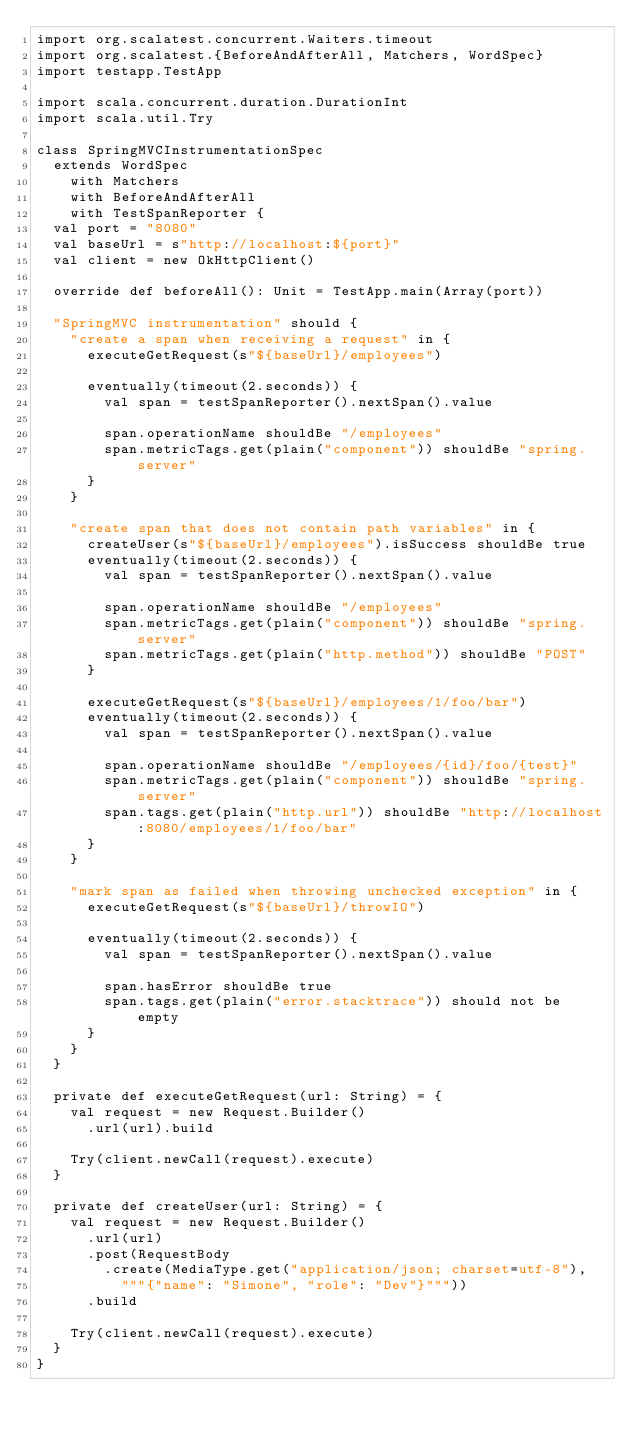<code> <loc_0><loc_0><loc_500><loc_500><_Scala_>import org.scalatest.concurrent.Waiters.timeout
import org.scalatest.{BeforeAndAfterAll, Matchers, WordSpec}
import testapp.TestApp

import scala.concurrent.duration.DurationInt
import scala.util.Try

class SpringMVCInstrumentationSpec
  extends WordSpec
    with Matchers
    with BeforeAndAfterAll
    with TestSpanReporter {
  val port = "8080"
  val baseUrl = s"http://localhost:${port}"
  val client = new OkHttpClient()

  override def beforeAll(): Unit = TestApp.main(Array(port))

  "SpringMVC instrumentation" should {
    "create a span when receiving a request" in {
      executeGetRequest(s"${baseUrl}/employees")

      eventually(timeout(2.seconds)) {
        val span = testSpanReporter().nextSpan().value

        span.operationName shouldBe "/employees"
        span.metricTags.get(plain("component")) shouldBe "spring.server"
      }
    }

    "create span that does not contain path variables" in {
      createUser(s"${baseUrl}/employees").isSuccess shouldBe true
      eventually(timeout(2.seconds)) {
        val span = testSpanReporter().nextSpan().value

        span.operationName shouldBe "/employees"
        span.metricTags.get(plain("component")) shouldBe "spring.server"
        span.metricTags.get(plain("http.method")) shouldBe "POST"
      }

      executeGetRequest(s"${baseUrl}/employees/1/foo/bar")
      eventually(timeout(2.seconds)) {
        val span = testSpanReporter().nextSpan().value

        span.operationName shouldBe "/employees/{id}/foo/{test}"
        span.metricTags.get(plain("component")) shouldBe "spring.server"
        span.tags.get(plain("http.url")) shouldBe "http://localhost:8080/employees/1/foo/bar"
      }
    }

    "mark span as failed when throwing unchecked exception" in {
      executeGetRequest(s"${baseUrl}/throwIO")

      eventually(timeout(2.seconds)) {
        val span = testSpanReporter().nextSpan().value

        span.hasError shouldBe true
        span.tags.get(plain("error.stacktrace")) should not be empty
      }
    }
  }

  private def executeGetRequest(url: String) = {
    val request = new Request.Builder()
      .url(url).build

    Try(client.newCall(request).execute)
  }

  private def createUser(url: String) = {
    val request = new Request.Builder()
      .url(url)
      .post(RequestBody
        .create(MediaType.get("application/json; charset=utf-8"),
          """{"name": "Simone", "role": "Dev"}"""))
      .build

    Try(client.newCall(request).execute)
  }
}
</code> 